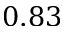Convert formula to latex. <formula><loc_0><loc_0><loc_500><loc_500>0 . 8 3</formula> 